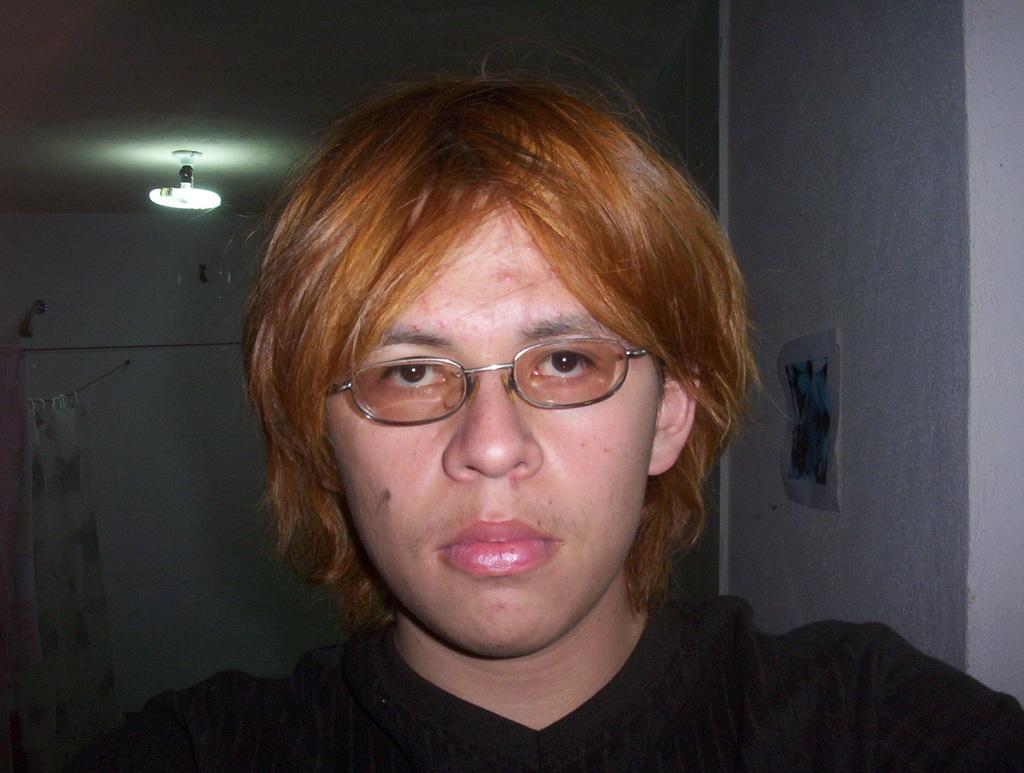Could you give a brief overview of what you see in this image? In this image we can see a person wearing spectacles and black dress. In the background, we can see a light and curtain. 